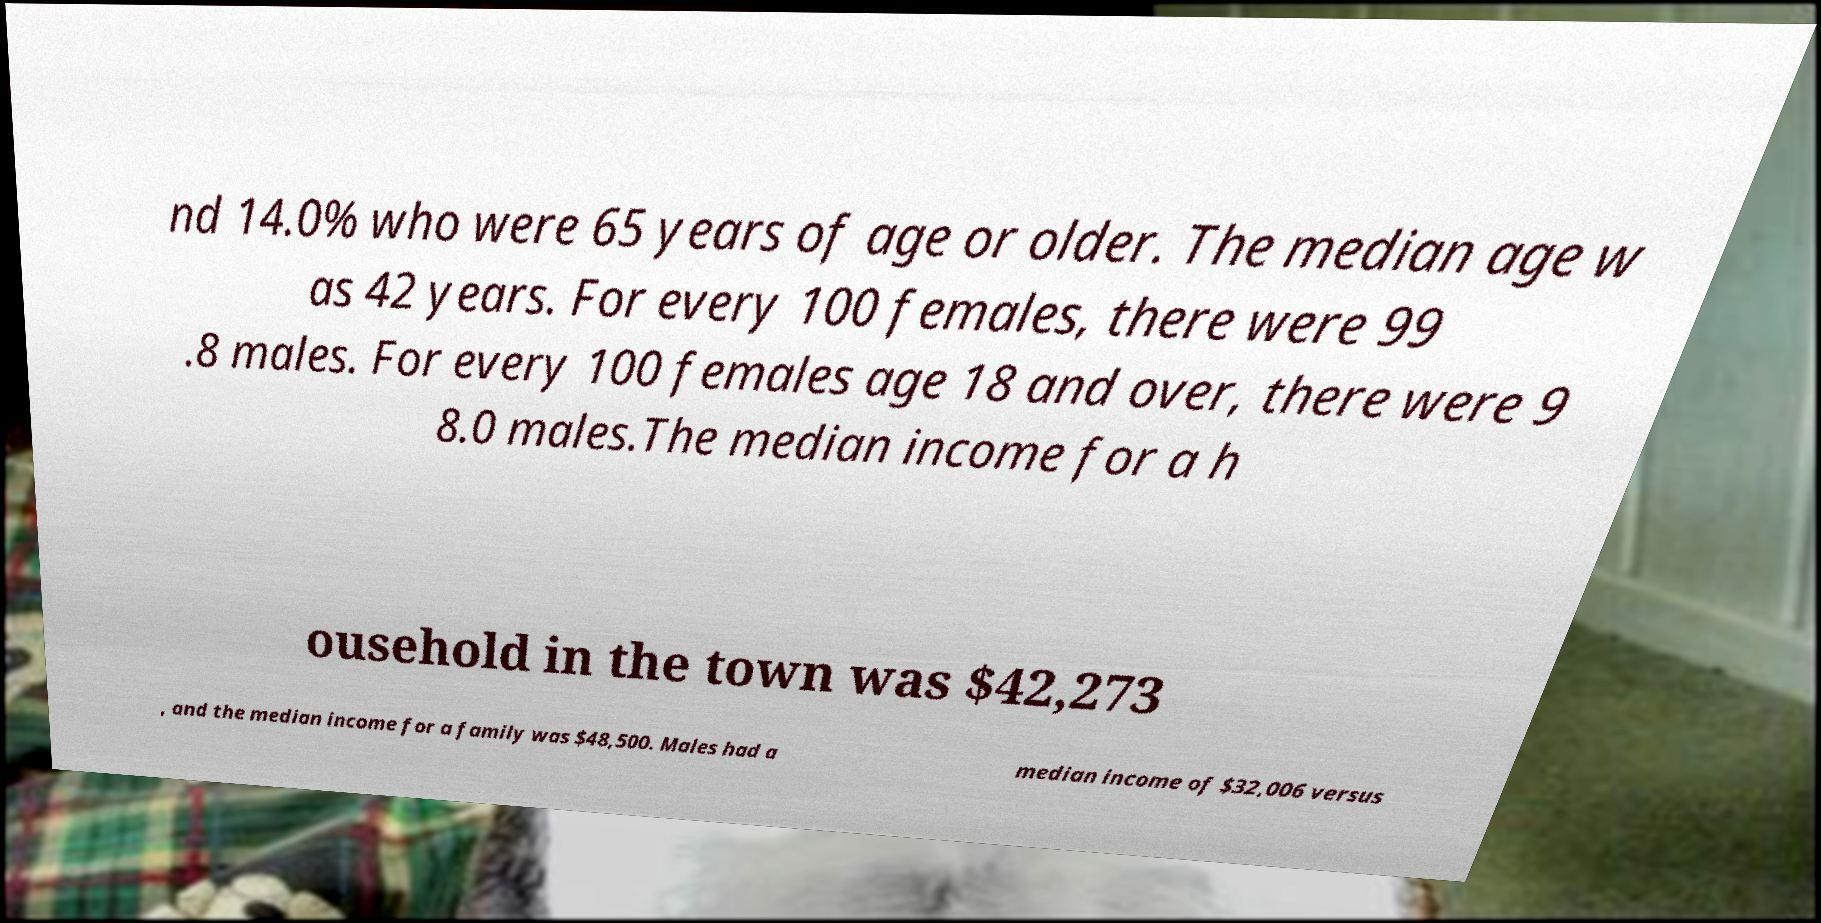For documentation purposes, I need the text within this image transcribed. Could you provide that? nd 14.0% who were 65 years of age or older. The median age w as 42 years. For every 100 females, there were 99 .8 males. For every 100 females age 18 and over, there were 9 8.0 males.The median income for a h ousehold in the town was $42,273 , and the median income for a family was $48,500. Males had a median income of $32,006 versus 